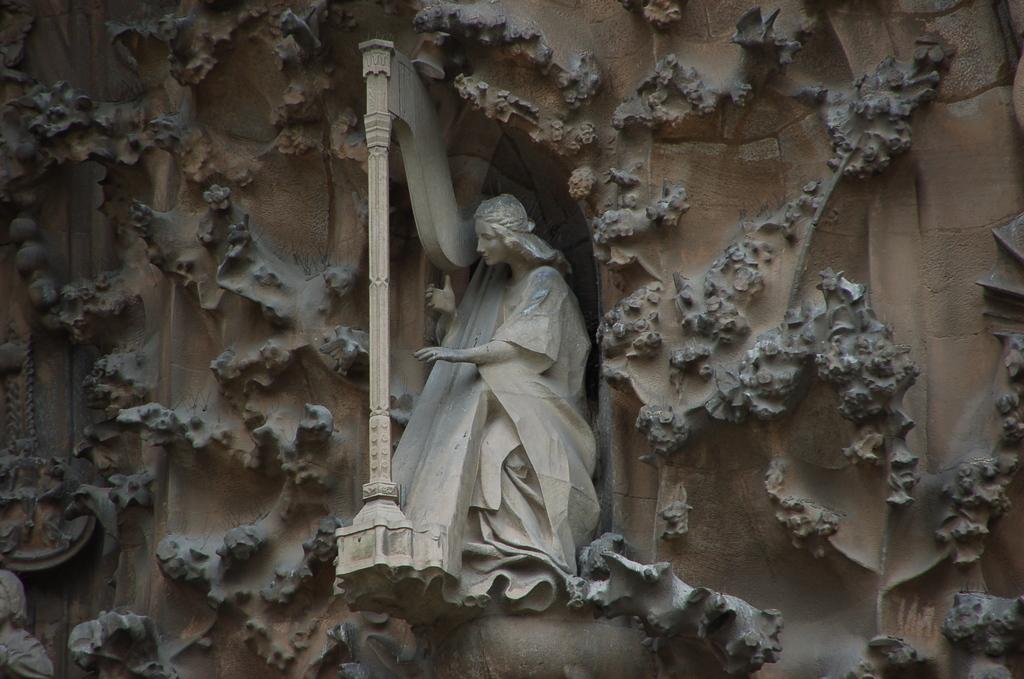How would you summarize this image in a sentence or two? In this image we can see a statue on the wall. 